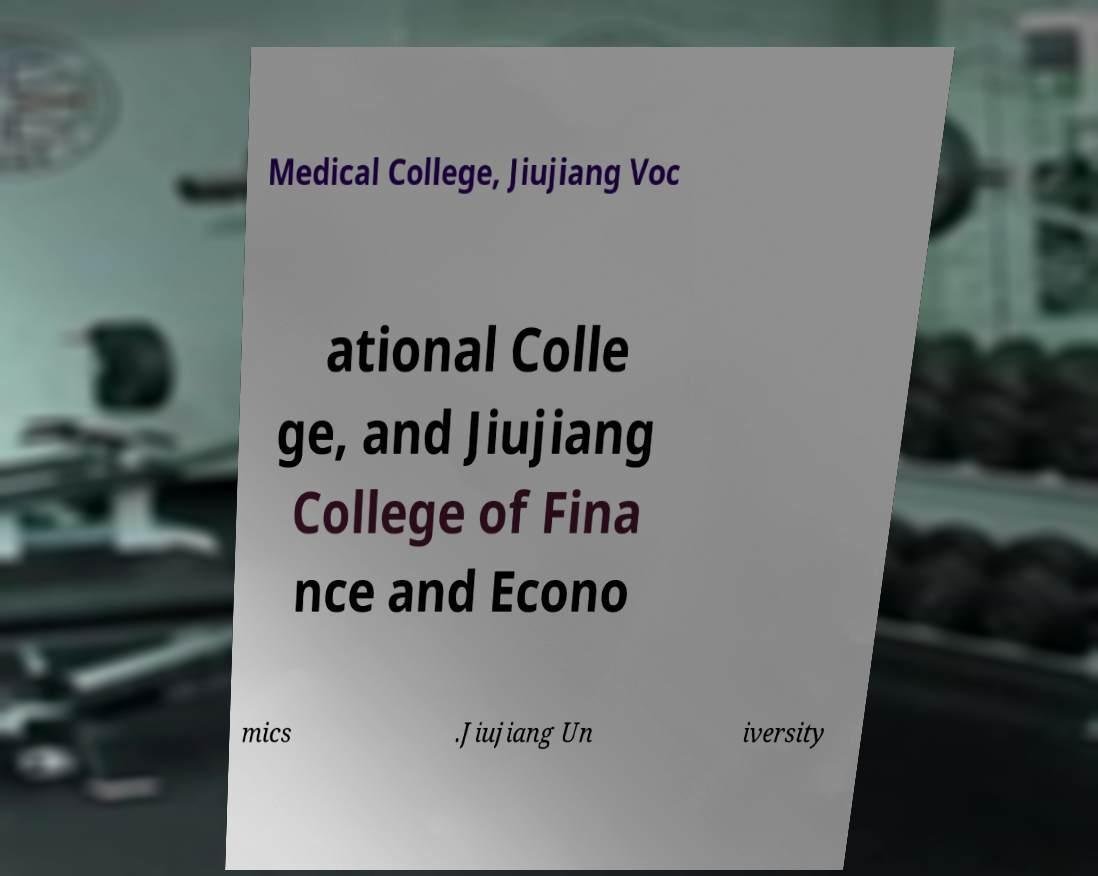For documentation purposes, I need the text within this image transcribed. Could you provide that? Medical College, Jiujiang Voc ational Colle ge, and Jiujiang College of Fina nce and Econo mics .Jiujiang Un iversity 